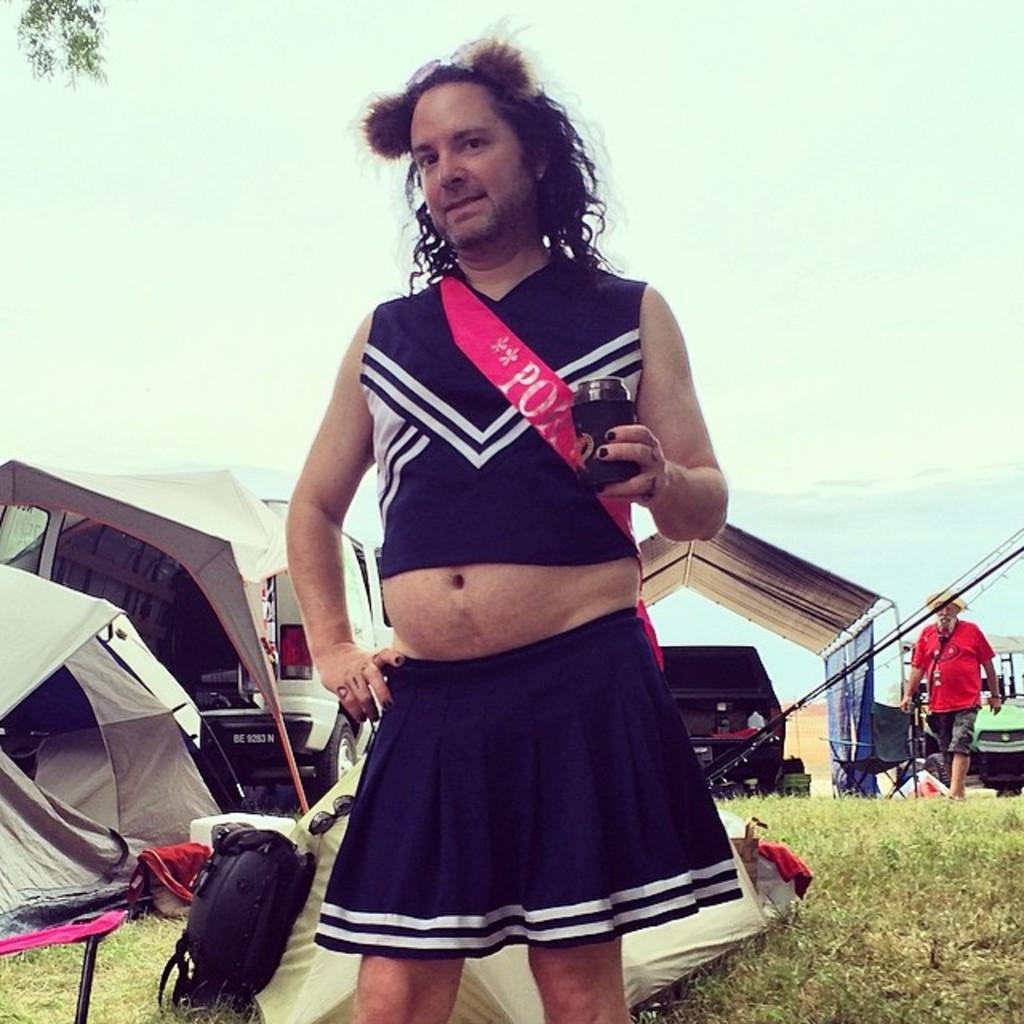<image>
Render a clear and concise summary of the photo. BE 9283 N is the designation of the license plate of the van. 